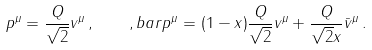<formula> <loc_0><loc_0><loc_500><loc_500>p ^ { \mu } = \frac { Q } { \sqrt { 2 } } v ^ { \mu } \, , \quad , b a r p ^ { \mu } = ( 1 - x ) \frac { Q } { \sqrt { 2 } } v ^ { \mu } + \frac { Q } { \sqrt { 2 } x } \bar { v } ^ { \mu } \, .</formula> 